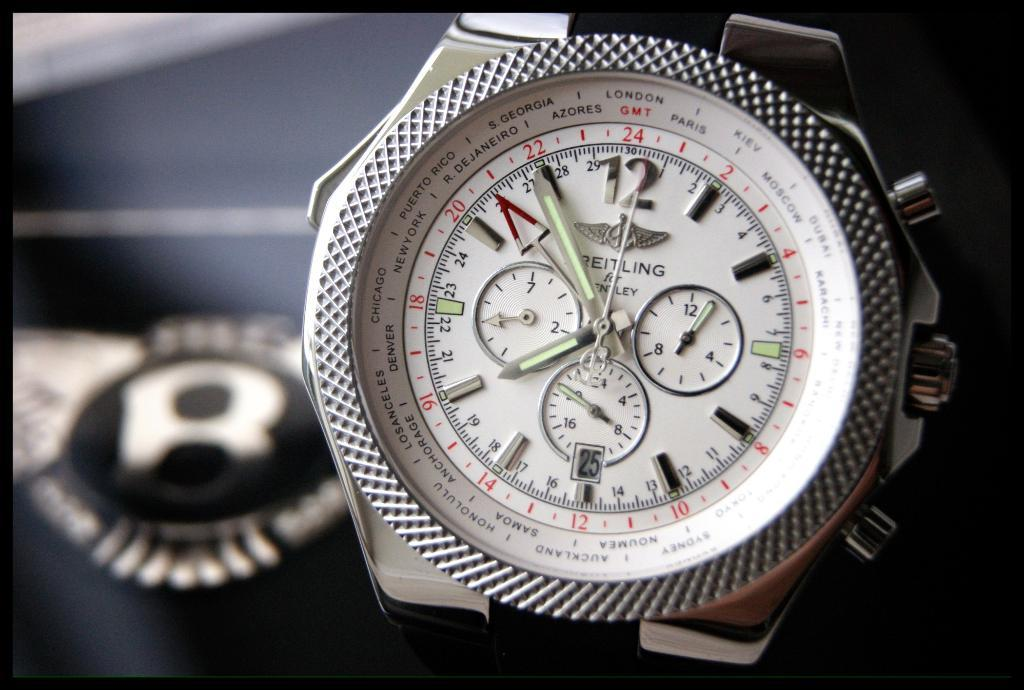What type of object is in the image? There is a hand watch in the image. Where is the hand watch located? The hand watch is on a table. What time is displayed on the hand watch? The time displayed on the watch is 8 o'clock. What type of team is playing in the image? There is no team present in the image; it features a hand watch on a table. How many crows can be seen in the image? There are no crows present in the image. 